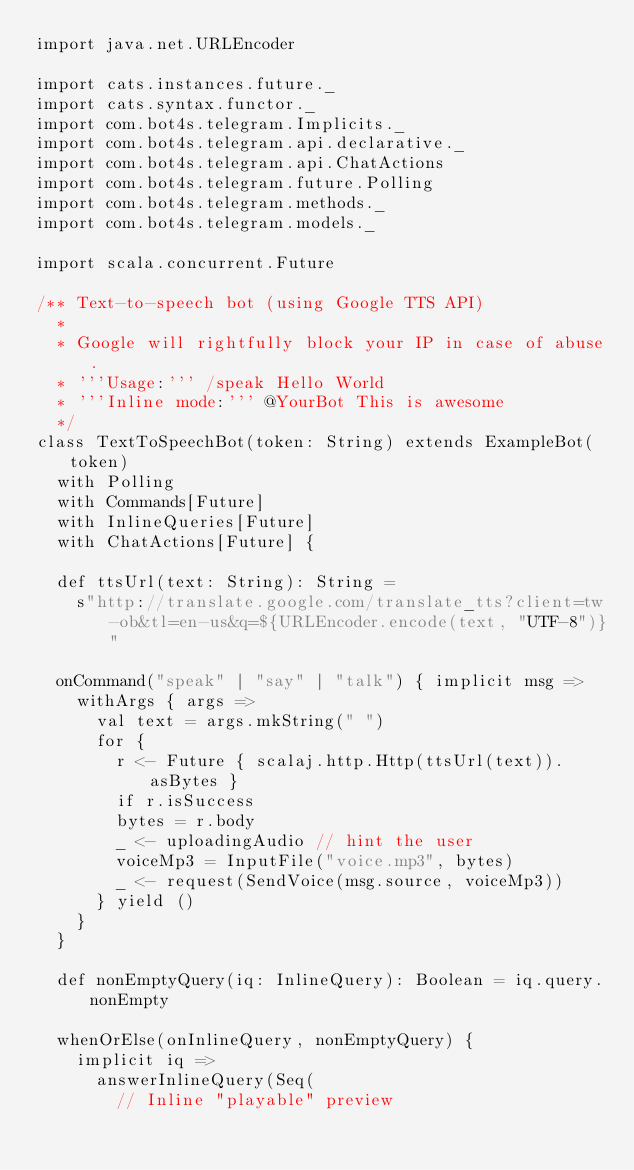<code> <loc_0><loc_0><loc_500><loc_500><_Scala_>import java.net.URLEncoder

import cats.instances.future._
import cats.syntax.functor._
import com.bot4s.telegram.Implicits._
import com.bot4s.telegram.api.declarative._
import com.bot4s.telegram.api.ChatActions
import com.bot4s.telegram.future.Polling
import com.bot4s.telegram.methods._
import com.bot4s.telegram.models._

import scala.concurrent.Future

/** Text-to-speech bot (using Google TTS API)
  *
  * Google will rightfully block your IP in case of abuse.
  * '''Usage:''' /speak Hello World
  * '''Inline mode:''' @YourBot This is awesome
  */
class TextToSpeechBot(token: String) extends ExampleBot(token)
  with Polling
  with Commands[Future]
  with InlineQueries[Future]
  with ChatActions[Future] {

  def ttsUrl(text: String): String =
    s"http://translate.google.com/translate_tts?client=tw-ob&tl=en-us&q=${URLEncoder.encode(text, "UTF-8")}"

  onCommand("speak" | "say" | "talk") { implicit msg =>
    withArgs { args =>
      val text = args.mkString(" ")
      for {
        r <- Future { scalaj.http.Http(ttsUrl(text)).asBytes }
        if r.isSuccess
        bytes = r.body
        _ <- uploadingAudio // hint the user
        voiceMp3 = InputFile("voice.mp3", bytes)
        _ <- request(SendVoice(msg.source, voiceMp3))
      } yield ()
    }
  }

  def nonEmptyQuery(iq: InlineQuery): Boolean = iq.query.nonEmpty

  whenOrElse(onInlineQuery, nonEmptyQuery) {
    implicit iq =>
      answerInlineQuery(Seq(
        // Inline "playable" preview</code> 